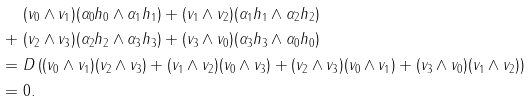<formula> <loc_0><loc_0><loc_500><loc_500>& ( v _ { 0 } \wedge v _ { 1 } ) ( \alpha _ { 0 } h _ { 0 } \wedge \alpha _ { 1 } h _ { 1 } ) + ( v _ { 1 } \wedge v _ { 2 } ) ( \alpha _ { 1 } h _ { 1 } \wedge \alpha _ { 2 } h _ { 2 } ) \\ + \ & ( v _ { 2 } \wedge v _ { 3 } ) ( \alpha _ { 2 } h _ { 2 } \wedge \alpha _ { 3 } h _ { 3 } ) + ( v _ { 3 } \wedge v _ { 0 } ) ( \alpha _ { 3 } h _ { 3 } \wedge \alpha _ { 0 } h _ { 0 } ) \\ = \ & D \left ( ( v _ { 0 } \wedge v _ { 1 } ) ( v _ { 2 } \wedge v _ { 3 } ) + ( v _ { 1 } \wedge v _ { 2 } ) ( v _ { 0 } \wedge v _ { 3 } ) + ( v _ { 2 } \wedge v _ { 3 } ) ( v _ { 0 } \wedge v _ { 1 } ) + ( v _ { 3 } \wedge v _ { 0 } ) ( v _ { 1 } \wedge v _ { 2 } ) \right ) \\ = \ & 0 .</formula> 